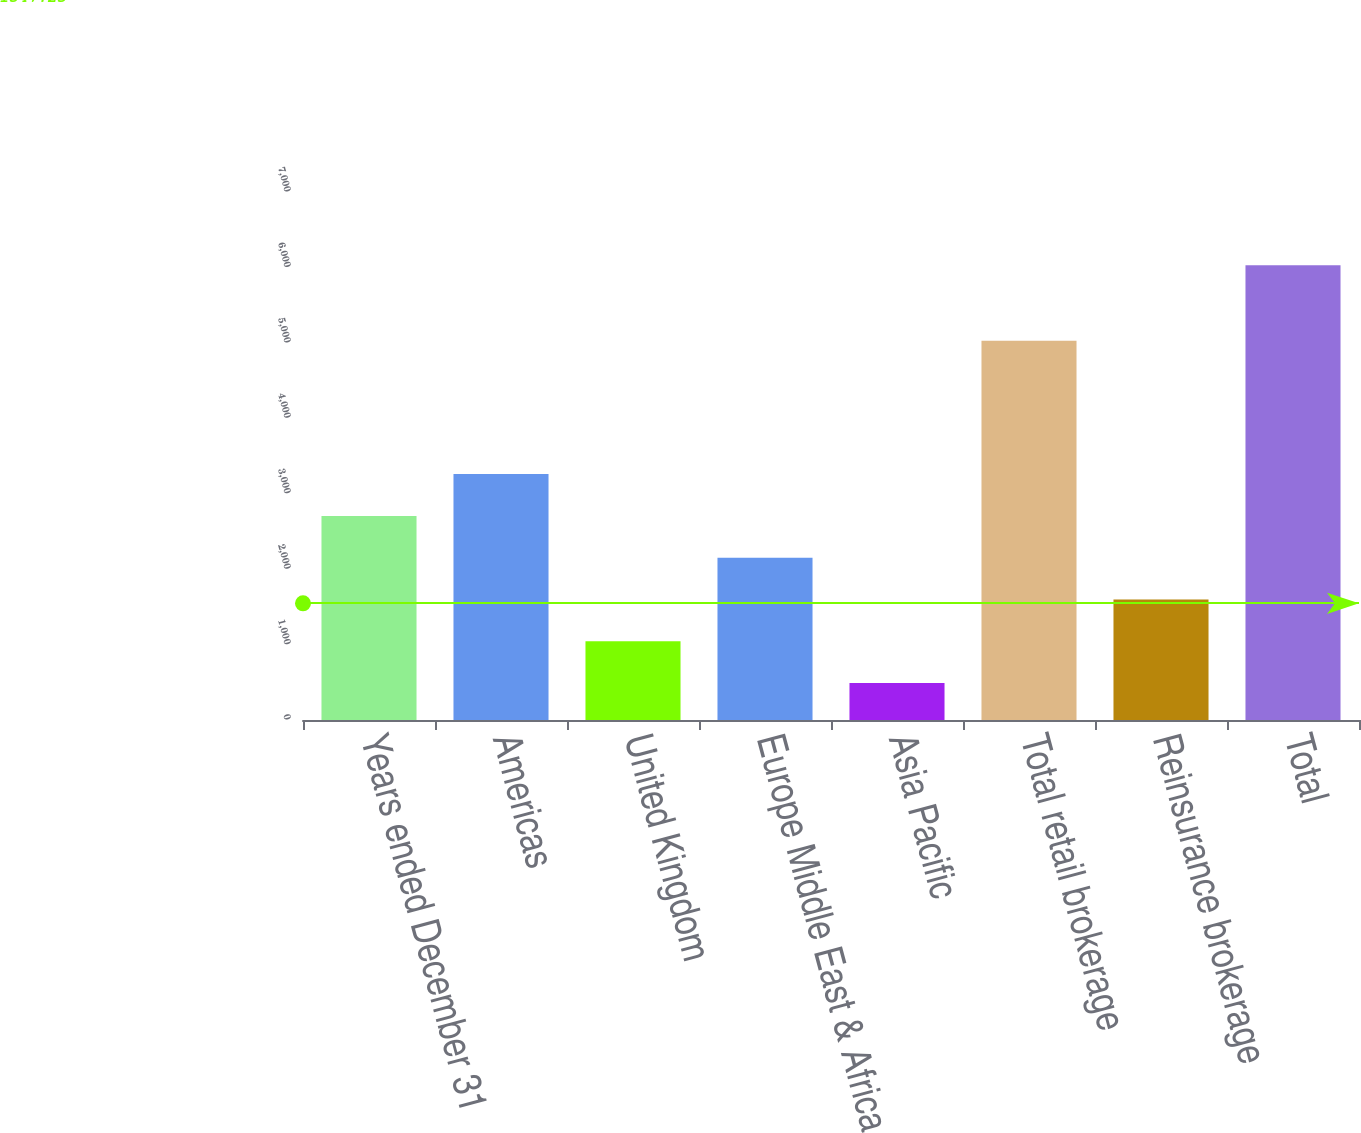Convert chart to OTSL. <chart><loc_0><loc_0><loc_500><loc_500><bar_chart><fcel>Years ended December 31<fcel>Americas<fcel>United Kingdom<fcel>Europe Middle East & Africa<fcel>Asia Pacific<fcel>Total retail brokerage<fcel>Reinsurance brokerage<fcel>Total<nl><fcel>2706.2<fcel>3260<fcel>1044.8<fcel>2152.4<fcel>491<fcel>5028<fcel>1598.6<fcel>6029<nl></chart> 